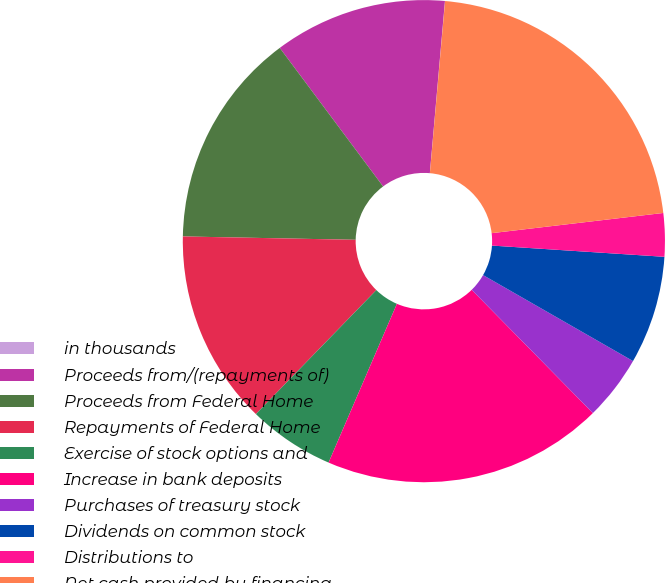<chart> <loc_0><loc_0><loc_500><loc_500><pie_chart><fcel>in thousands<fcel>Proceeds from/(repayments of)<fcel>Proceeds from Federal Home<fcel>Repayments of Federal Home<fcel>Exercise of stock options and<fcel>Increase in bank deposits<fcel>Purchases of treasury stock<fcel>Dividends on common stock<fcel>Distributions to<fcel>Net cash provided by financing<nl><fcel>0.01%<fcel>11.59%<fcel>14.49%<fcel>13.04%<fcel>5.8%<fcel>18.83%<fcel>4.35%<fcel>7.25%<fcel>2.9%<fcel>21.73%<nl></chart> 